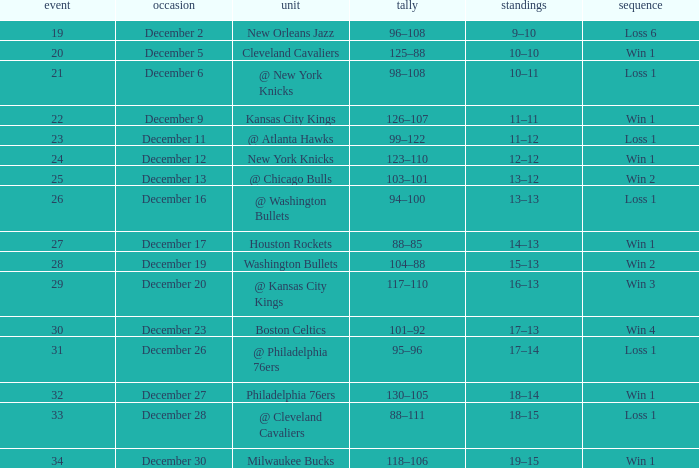What Game had a Score of 101–92? 30.0. 